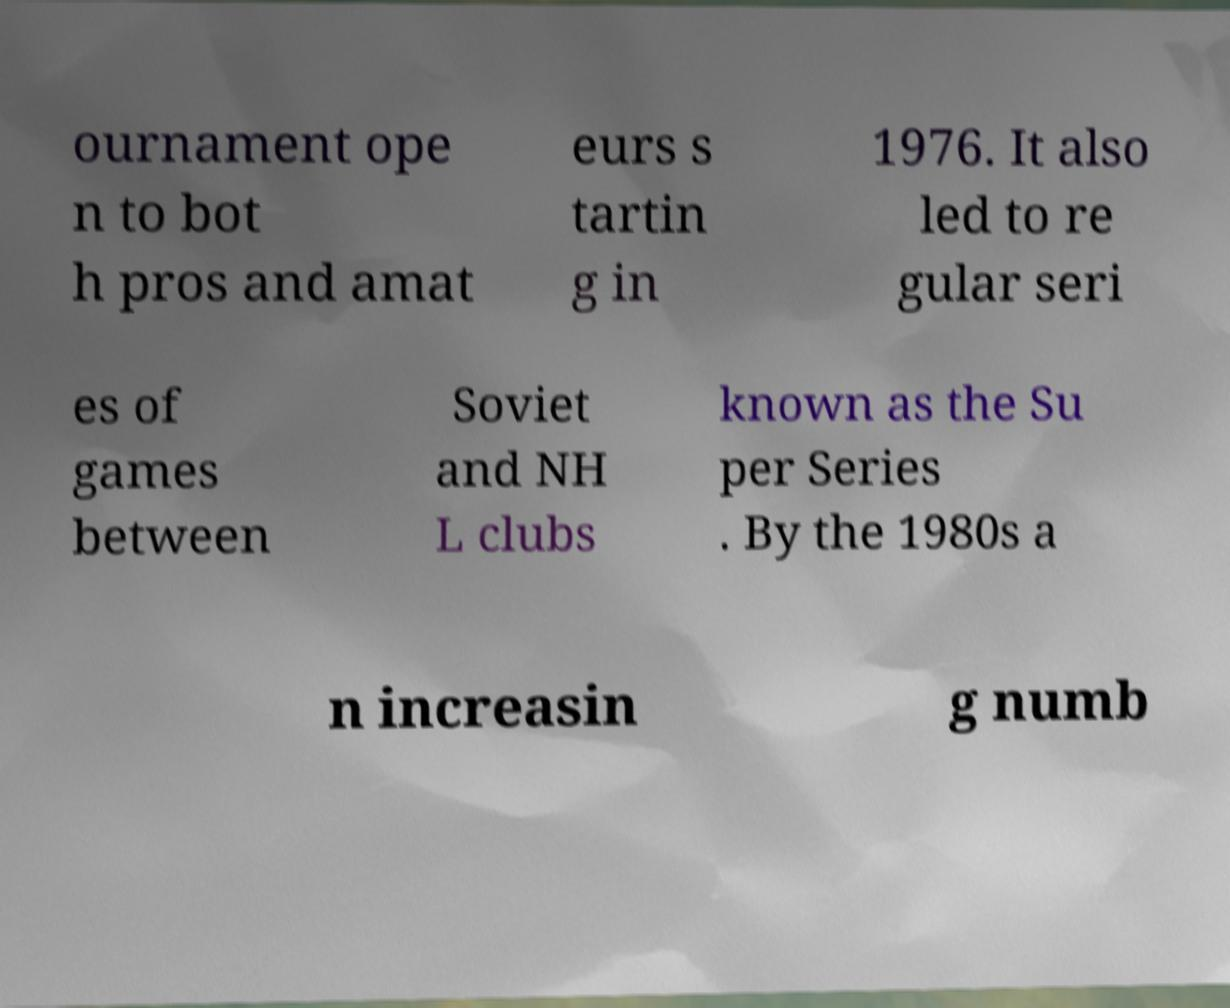Please identify and transcribe the text found in this image. ournament ope n to bot h pros and amat eurs s tartin g in 1976. It also led to re gular seri es of games between Soviet and NH L clubs known as the Su per Series . By the 1980s a n increasin g numb 